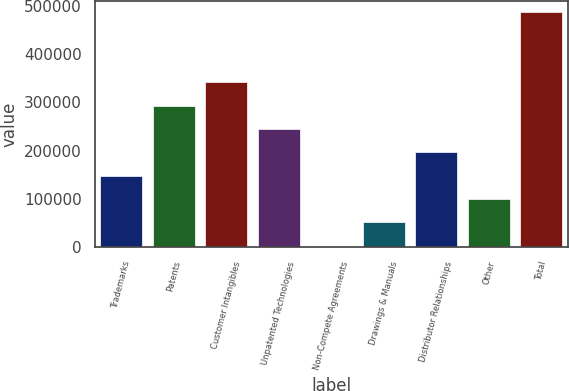Convert chart. <chart><loc_0><loc_0><loc_500><loc_500><bar_chart><fcel>Trademarks<fcel>Patents<fcel>Customer Intangibles<fcel>Unpatented Technologies<fcel>Non-Compete Agreements<fcel>Drawings & Manuals<fcel>Distributor Relationships<fcel>Other<fcel>Total<nl><fcel>148392<fcel>293473<fcel>341834<fcel>245112<fcel>3310<fcel>51670.5<fcel>196752<fcel>100031<fcel>486915<nl></chart> 